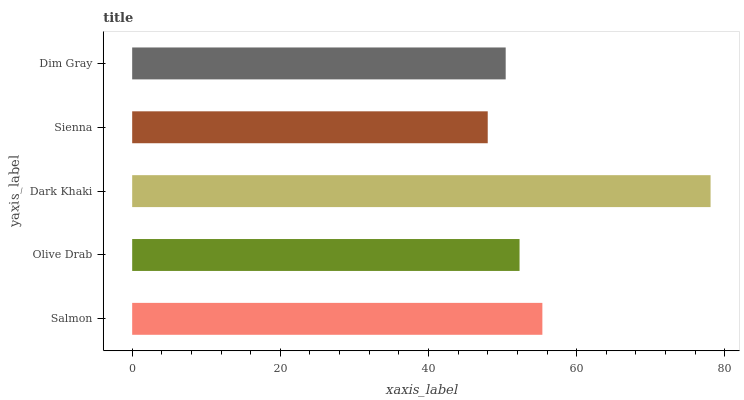Is Sienna the minimum?
Answer yes or no. Yes. Is Dark Khaki the maximum?
Answer yes or no. Yes. Is Olive Drab the minimum?
Answer yes or no. No. Is Olive Drab the maximum?
Answer yes or no. No. Is Salmon greater than Olive Drab?
Answer yes or no. Yes. Is Olive Drab less than Salmon?
Answer yes or no. Yes. Is Olive Drab greater than Salmon?
Answer yes or no. No. Is Salmon less than Olive Drab?
Answer yes or no. No. Is Olive Drab the high median?
Answer yes or no. Yes. Is Olive Drab the low median?
Answer yes or no. Yes. Is Sienna the high median?
Answer yes or no. No. Is Dark Khaki the low median?
Answer yes or no. No. 